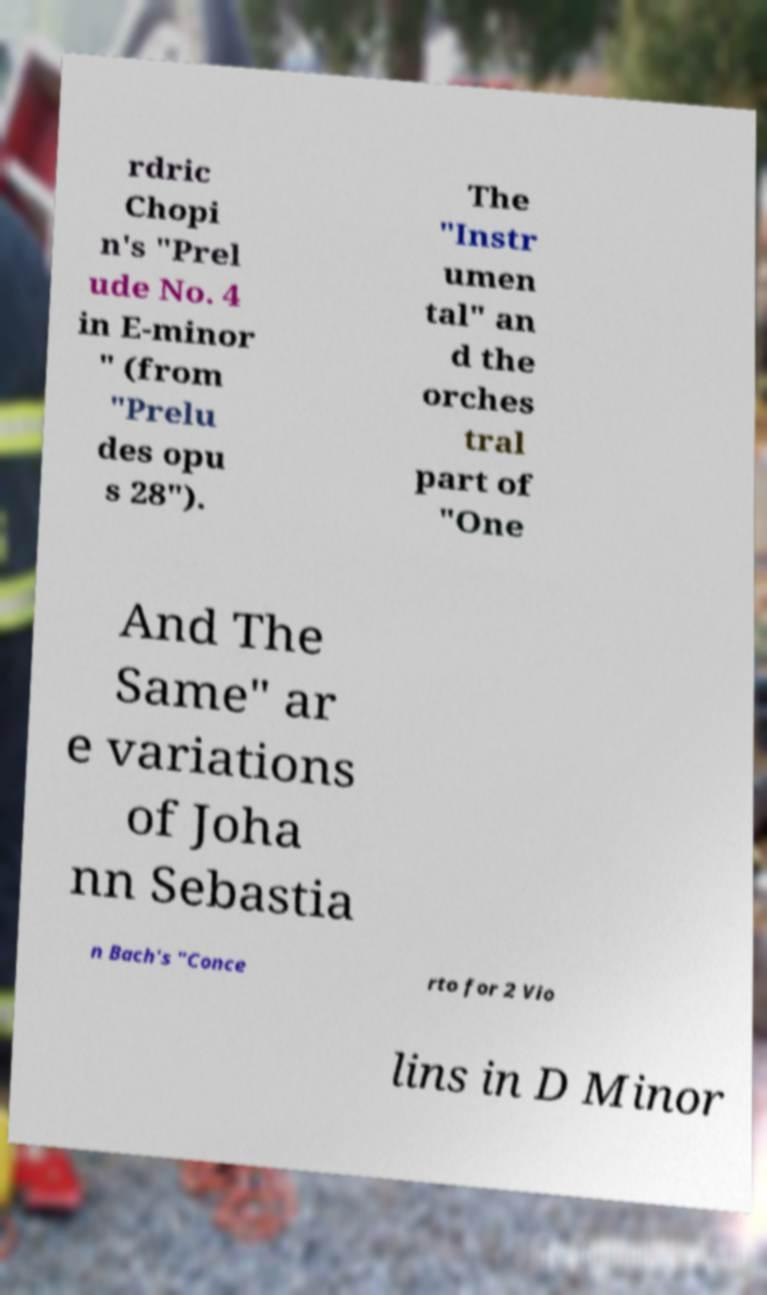I need the written content from this picture converted into text. Can you do that? rdric Chopi n's "Prel ude No. 4 in E-minor " (from "Prelu des opu s 28"). The "Instr umen tal" an d the orches tral part of "One And The Same" ar e variations of Joha nn Sebastia n Bach's "Conce rto for 2 Vio lins in D Minor 